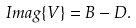<formula> <loc_0><loc_0><loc_500><loc_500>I m a g \{ V \} = B - D .</formula> 